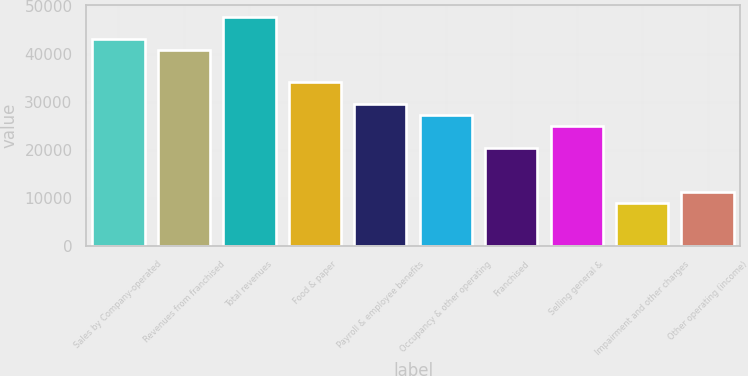<chart> <loc_0><loc_0><loc_500><loc_500><bar_chart><fcel>Sales by Company-operated<fcel>Revenues from franchised<fcel>Total revenues<fcel>Food & paper<fcel>Payroll & employee benefits<fcel>Occupancy & other operating<fcel>Franchised<fcel>Selling general &<fcel>Impairment and other charges<fcel>Other operating (income)<nl><fcel>43213.1<fcel>40938.8<fcel>47761.6<fcel>34116<fcel>29567.5<fcel>27293.3<fcel>20470.5<fcel>25019<fcel>9099.12<fcel>11373.4<nl></chart> 